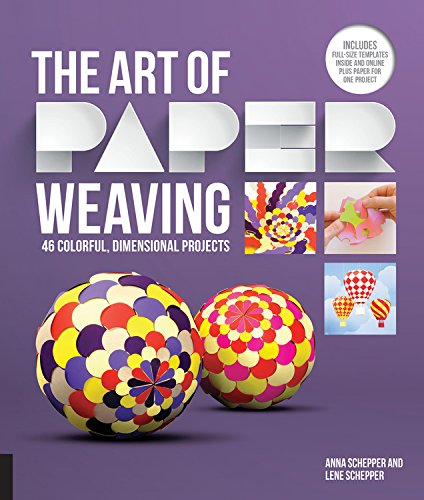Who is the author of this book? The book 'The Art of Paper Weaving' is authored by Anna Schepper, who, along with Lene Schepper, brings a creative approach to paper crafts. 